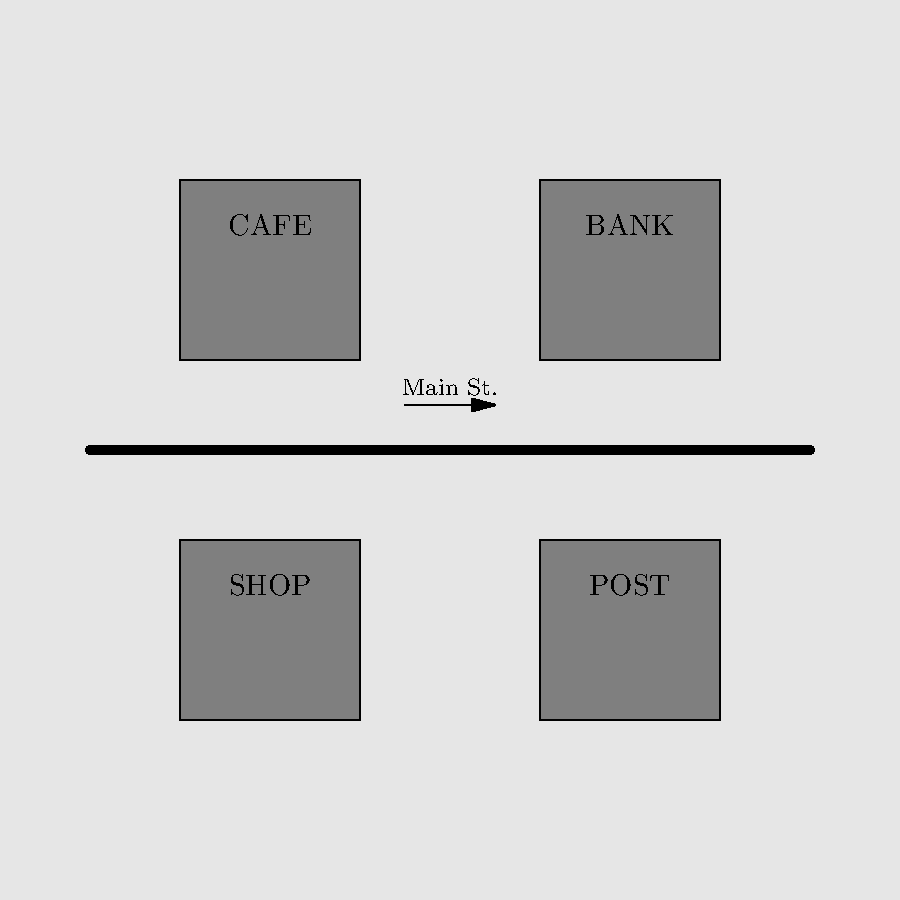In the signage layout of Sandy's town center, which typographic principle is most prominently demonstrated by the consistent use of all-capital letters for business names? To answer this question, let's analyze the typographic principles at play in the signage:

1. Consistency: All business names (CAFE, BANK, SHOP, POST) are written in capital letters.
2. Legibility: Capital letters are used for short, important information that needs to be easily read from a distance.
3. Hierarchy: The use of all-caps for business names creates a clear distinction from other text (e.g., "Main St.").
4. Contrast: The capital letters stand out against the buildings and street layout.

The most prominent principle demonstrated here is legibility. All-caps are often used in signage because:

a) They create a uniform letter height, making words more recognizable as shapes.
b) They are easier to read from various angles and distances.
c) They convey importance and urgency, which is crucial for business signage.

While consistency is also demonstrated, legibility is the primary reason for using all-caps in this context, as it directly relates to the function of signage in a town center.
Answer: Legibility 